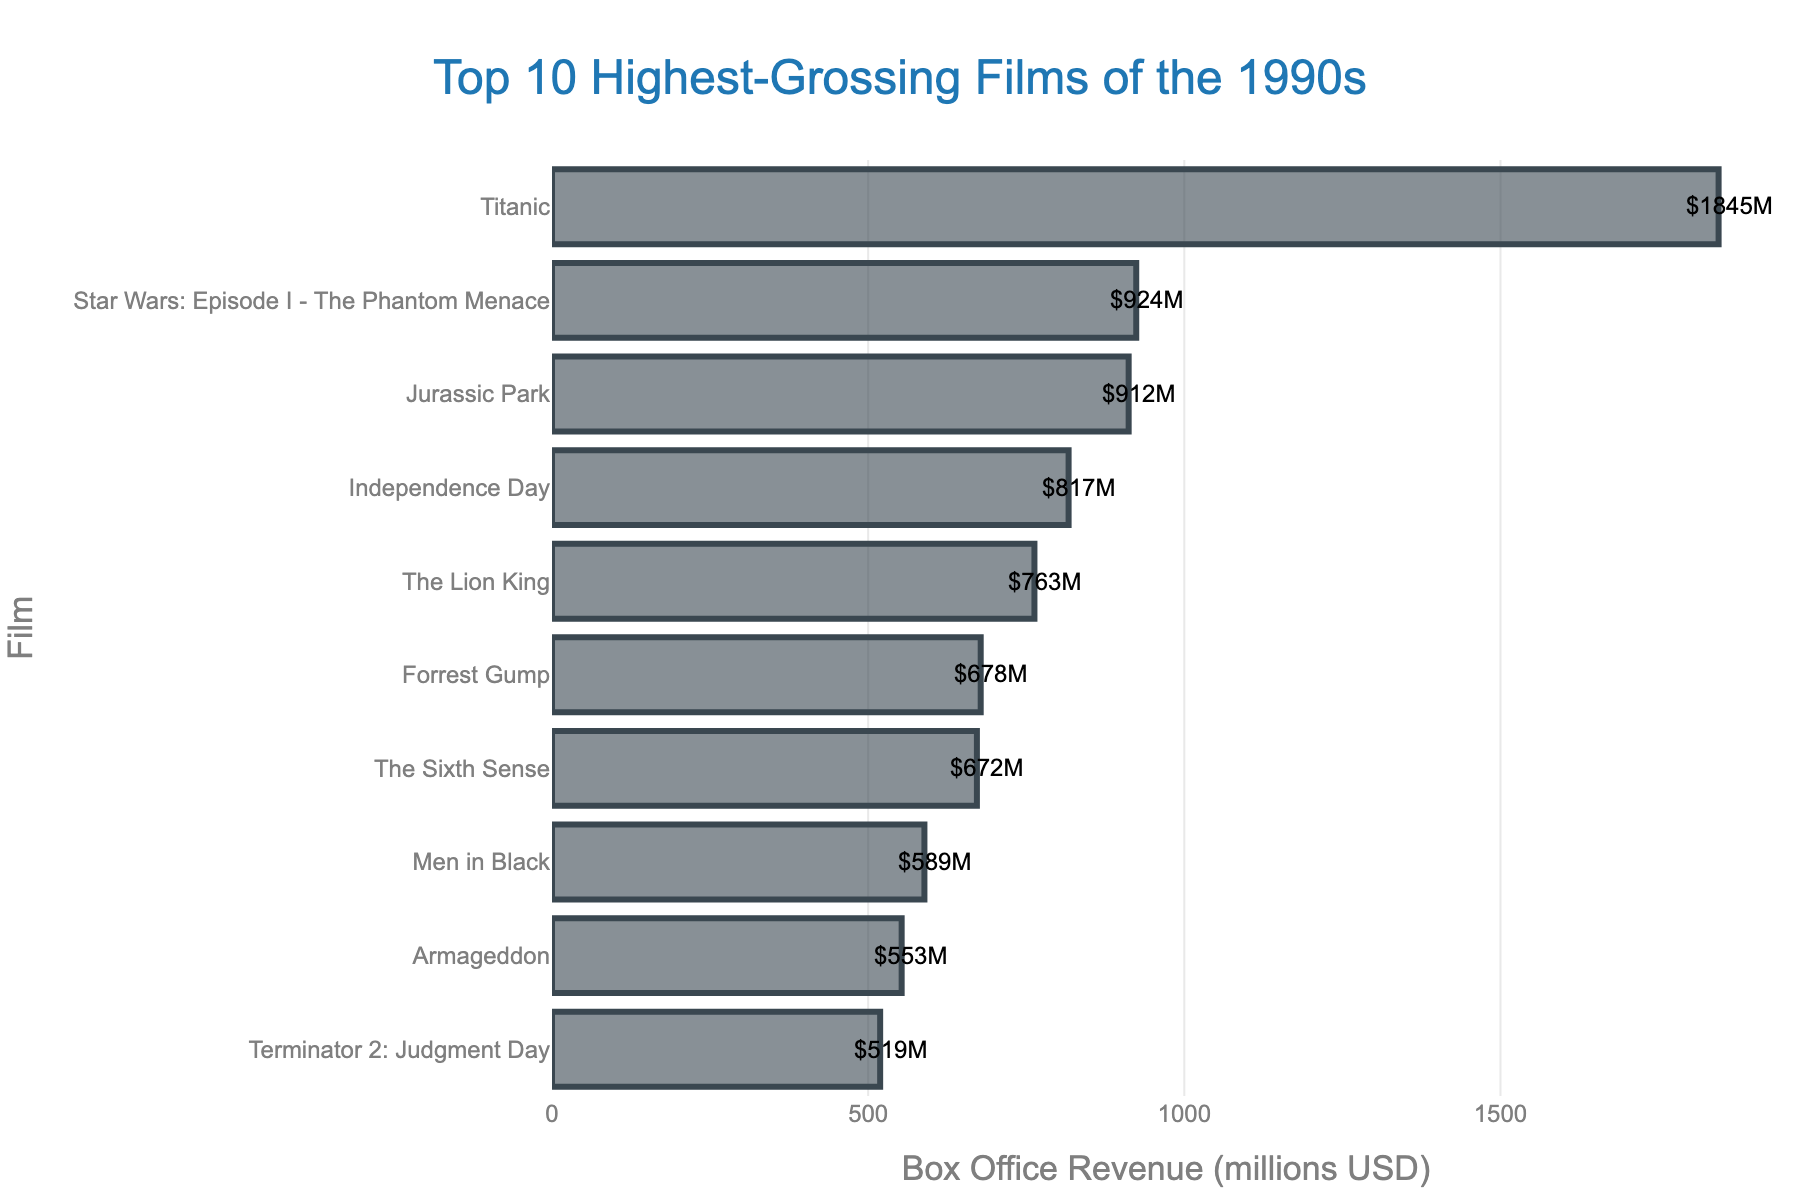Which film has the highest box office revenue in the 1990s? The highest bar corresponds to "Titanic" with $1845 million.
Answer: Titanic What is the difference in revenue between 'Titanic' and 'Star Wars: Episode I - The Phantom Menace'? The bar for "Titanic" is at $1845M and for "Star Wars: Episode I - The Phantom Menace" is at $924M. The difference is $1845M - $924M = $921M.
Answer: $921 million Which film is ranked fourth in terms of box office revenue? The fourth highest bar belongs to "Independence Day" with $817 million.
Answer: Independence Day What is the combined revenue of 'Jurassic Park' and 'The Lion King'? The bar for "Jurassic Park" is at $912M and "The Lion King" is at $763M. The combined revenue is $912M + $763M = $1675M.
Answer: $1675 million How much more revenue did 'Forrest Gump' generate compared to 'Terminator 2: Judgment Day'? "Forrest Gump" generated $678M and "Terminator 2: Judgment Day" generated $519M. The difference is $678M - $519M = $159M.
Answer: $159 million Which films generated less than $600 million in revenue? The bars representing less than $600M are "Armageddon" ($553M) and "Terminator 2: Judgment Day" ($519M).
Answer: Armageddon and Terminator 2: Judgment Day What is the average revenue of the top 10 highest-grossing films of the 1990s? Summing the revenues of all films: $1845M + $924M + $912M + $817M + $763M + $678M + $672M + $589M + $553M + $519M = $8272M. The average is $8272M / 10 = $827.2M.
Answer: $827.2 million Which film has the smallest box office revenue in the 1990s? The shortest bar corresponds to "Terminator 2: Judgment Day" with $519 million.
Answer: Terminator 2: Judgment Day 